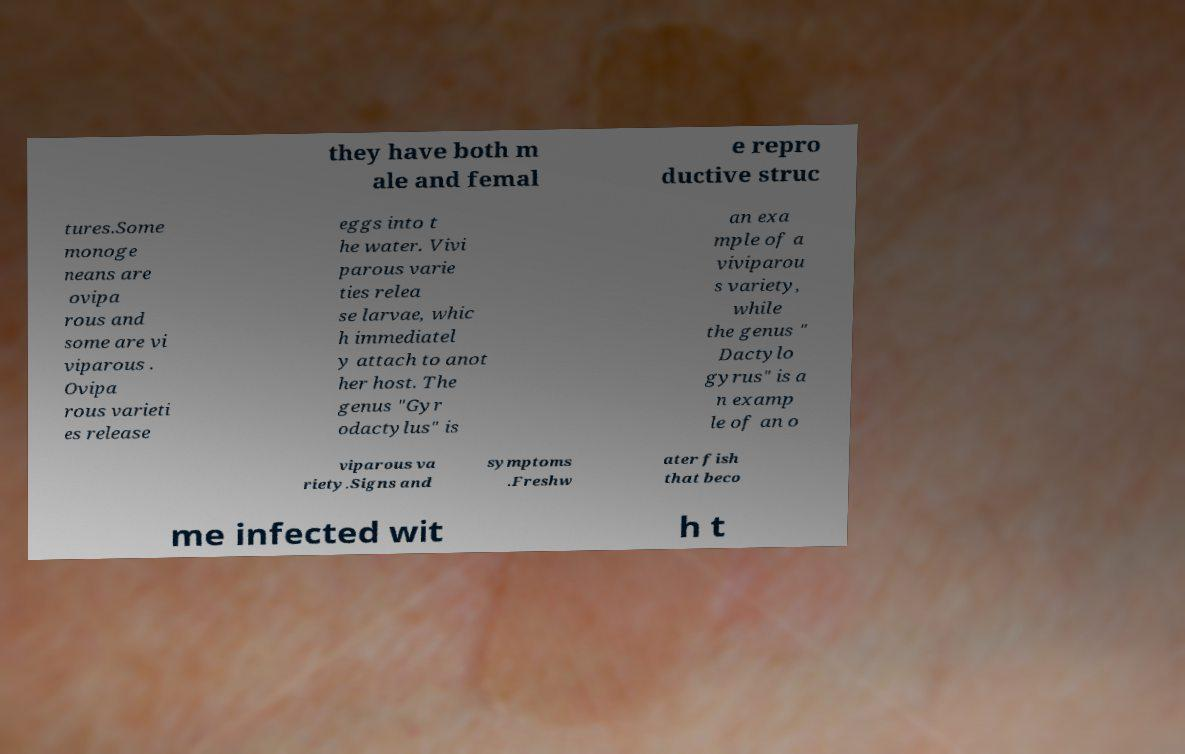Could you assist in decoding the text presented in this image and type it out clearly? they have both m ale and femal e repro ductive struc tures.Some monoge neans are ovipa rous and some are vi viparous . Ovipa rous varieti es release eggs into t he water. Vivi parous varie ties relea se larvae, whic h immediatel y attach to anot her host. The genus "Gyr odactylus" is an exa mple of a viviparou s variety, while the genus " Dactylo gyrus" is a n examp le of an o viparous va riety.Signs and symptoms .Freshw ater fish that beco me infected wit h t 